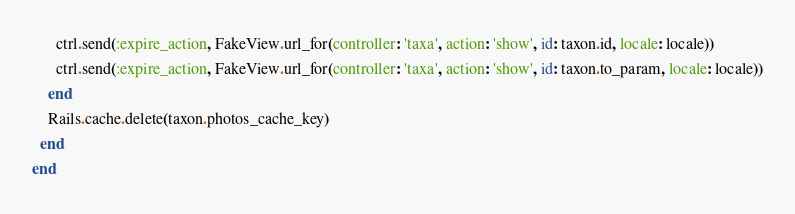<code> <loc_0><loc_0><loc_500><loc_500><_Ruby_>      ctrl.send(:expire_action, FakeView.url_for(controller: 'taxa', action: 'show', id: taxon.id, locale: locale))
      ctrl.send(:expire_action, FakeView.url_for(controller: 'taxa', action: 'show', id: taxon.to_param, locale: locale))
    end
    Rails.cache.delete(taxon.photos_cache_key)
  end
end
</code> 